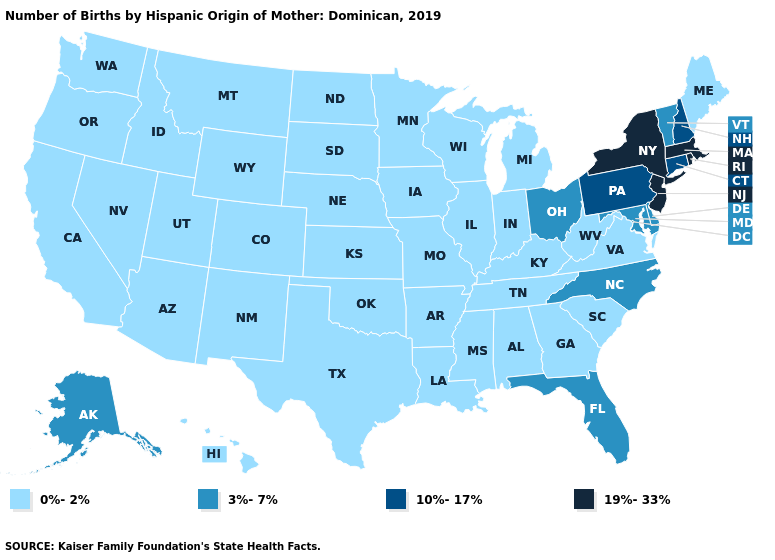What is the value of Connecticut?
Be succinct. 10%-17%. Does Louisiana have the highest value in the USA?
Concise answer only. No. Name the states that have a value in the range 0%-2%?
Concise answer only. Alabama, Arizona, Arkansas, California, Colorado, Georgia, Hawaii, Idaho, Illinois, Indiana, Iowa, Kansas, Kentucky, Louisiana, Maine, Michigan, Minnesota, Mississippi, Missouri, Montana, Nebraska, Nevada, New Mexico, North Dakota, Oklahoma, Oregon, South Carolina, South Dakota, Tennessee, Texas, Utah, Virginia, Washington, West Virginia, Wisconsin, Wyoming. Which states hav the highest value in the West?
Concise answer only. Alaska. Does the map have missing data?
Answer briefly. No. Does the first symbol in the legend represent the smallest category?
Answer briefly. Yes. Name the states that have a value in the range 3%-7%?
Concise answer only. Alaska, Delaware, Florida, Maryland, North Carolina, Ohio, Vermont. What is the lowest value in states that border Ohio?
Concise answer only. 0%-2%. Name the states that have a value in the range 3%-7%?
Give a very brief answer. Alaska, Delaware, Florida, Maryland, North Carolina, Ohio, Vermont. What is the value of North Dakota?
Write a very short answer. 0%-2%. Among the states that border New Jersey , which have the highest value?
Short answer required. New York. Name the states that have a value in the range 19%-33%?
Write a very short answer. Massachusetts, New Jersey, New York, Rhode Island. Does Kentucky have the same value as Maryland?
Keep it brief. No. Name the states that have a value in the range 3%-7%?
Short answer required. Alaska, Delaware, Florida, Maryland, North Carolina, Ohio, Vermont. 